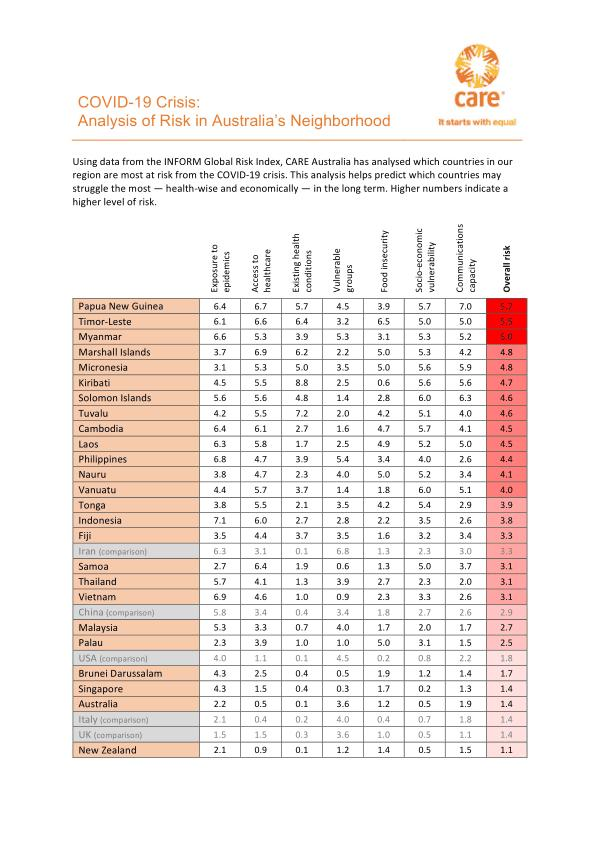Highlight a few significant elements in this photo. According to the risk index for exposure to epidemics, Brunei Darussalam and Singapore have a risk index of 4.3. Iran has the highest risk index with regard to vulnerable groups, according to the country's risk index with regard to vulnerable groups. The risk index for exposure to epidemics in Papua New Guinea is higher than that of New Zealand, with a difference of 4.3. The risk index for exposure to epidemics in Myanmar is higher than that of Solomon Islands. The two highest risk areas for New Zealand in terms of potential outbreaks of infectious diseases are exposure to epidemics and the communications capacity to respond to such outbreaks. 